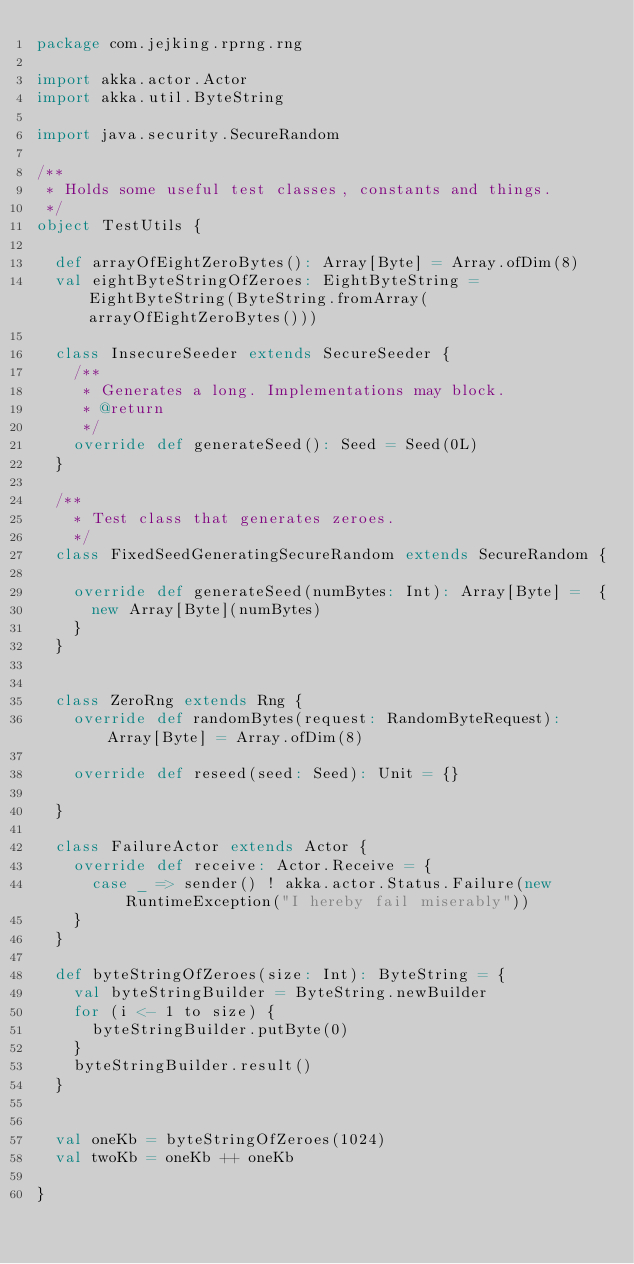Convert code to text. <code><loc_0><loc_0><loc_500><loc_500><_Scala_>package com.jejking.rprng.rng

import akka.actor.Actor
import akka.util.ByteString

import java.security.SecureRandom

/**
 * Holds some useful test classes, constants and things.
 */
object TestUtils {

  def arrayOfEightZeroBytes(): Array[Byte] = Array.ofDim(8)
  val eightByteStringOfZeroes: EightByteString = EightByteString(ByteString.fromArray(arrayOfEightZeroBytes()))

  class InsecureSeeder extends SecureSeeder {
    /**
     * Generates a long. Implementations may block.
     * @return
     */
    override def generateSeed(): Seed = Seed(0L)
  }

  /**
    * Test class that generates zeroes.
    */
  class FixedSeedGeneratingSecureRandom extends SecureRandom {

    override def generateSeed(numBytes: Int): Array[Byte] =  {
      new Array[Byte](numBytes)
    }
  }


  class ZeroRng extends Rng {
    override def randomBytes(request: RandomByteRequest): Array[Byte] = Array.ofDim(8)

    override def reseed(seed: Seed): Unit = {}

  }

  class FailureActor extends Actor {
    override def receive: Actor.Receive = {
      case _ => sender() ! akka.actor.Status.Failure(new RuntimeException("I hereby fail miserably"))
    }
  }

  def byteStringOfZeroes(size: Int): ByteString = {
    val byteStringBuilder = ByteString.newBuilder
    for (i <- 1 to size) {
      byteStringBuilder.putByte(0)
    }
    byteStringBuilder.result()
  }


  val oneKb = byteStringOfZeroes(1024)
  val twoKb = oneKb ++ oneKb

}
</code> 